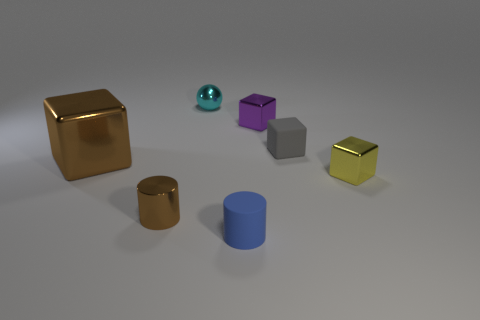What number of other things are made of the same material as the big brown cube?
Keep it short and to the point. 4. There is a tiny matte object behind the small blue object; does it have the same shape as the small object that is behind the purple shiny thing?
Your answer should be compact. No. What color is the small shiny sphere?
Keep it short and to the point. Cyan. How many metal things are either tiny spheres or large things?
Provide a succinct answer. 2. What is the color of the other tiny shiny thing that is the same shape as the small purple thing?
Offer a terse response. Yellow. Is there a big blue rubber cylinder?
Keep it short and to the point. No. Do the small cylinder to the right of the sphere and the object that is left of the tiny shiny cylinder have the same material?
Offer a terse response. No. There is another object that is the same color as the large shiny thing; what is its shape?
Give a very brief answer. Cylinder. What number of objects are tiny shiny things that are in front of the ball or tiny gray things that are right of the small blue thing?
Your answer should be compact. 4. Do the tiny rubber thing that is in front of the big shiny cube and the metal block in front of the large brown cube have the same color?
Your response must be concise. No. 